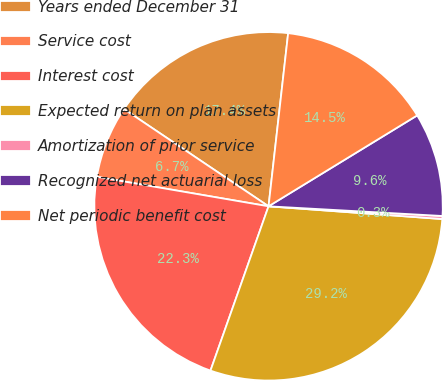Convert chart to OTSL. <chart><loc_0><loc_0><loc_500><loc_500><pie_chart><fcel>Years ended December 31<fcel>Service cost<fcel>Interest cost<fcel>Expected return on plan assets<fcel>Amortization of prior service<fcel>Recognized net actuarial loss<fcel>Net periodic benefit cost<nl><fcel>17.37%<fcel>6.72%<fcel>22.3%<fcel>29.24%<fcel>0.28%<fcel>9.62%<fcel>14.47%<nl></chart> 